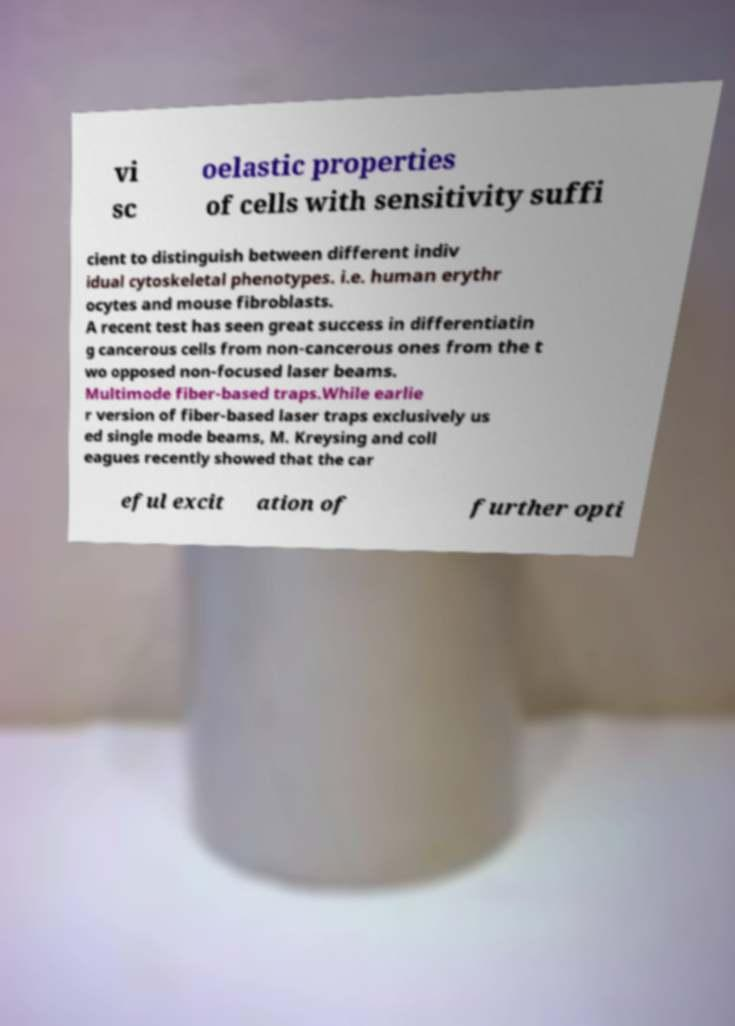Please identify and transcribe the text found in this image. vi sc oelastic properties of cells with sensitivity suffi cient to distinguish between different indiv idual cytoskeletal phenotypes. i.e. human erythr ocytes and mouse fibroblasts. A recent test has seen great success in differentiatin g cancerous cells from non-cancerous ones from the t wo opposed non-focused laser beams. Multimode fiber-based traps.While earlie r version of fiber-based laser traps exclusively us ed single mode beams, M. Kreysing and coll eagues recently showed that the car eful excit ation of further opti 